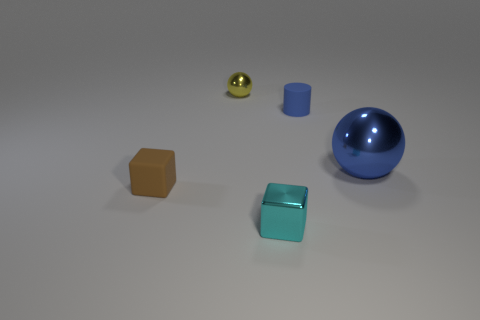Add 3 large blue shiny things. How many objects exist? 8 Subtract all cylinders. How many objects are left? 4 Add 5 small metal balls. How many small metal balls exist? 6 Subtract 0 cyan cylinders. How many objects are left? 5 Subtract all small cyan objects. Subtract all blue metallic spheres. How many objects are left? 3 Add 2 cyan metallic cubes. How many cyan metallic cubes are left? 3 